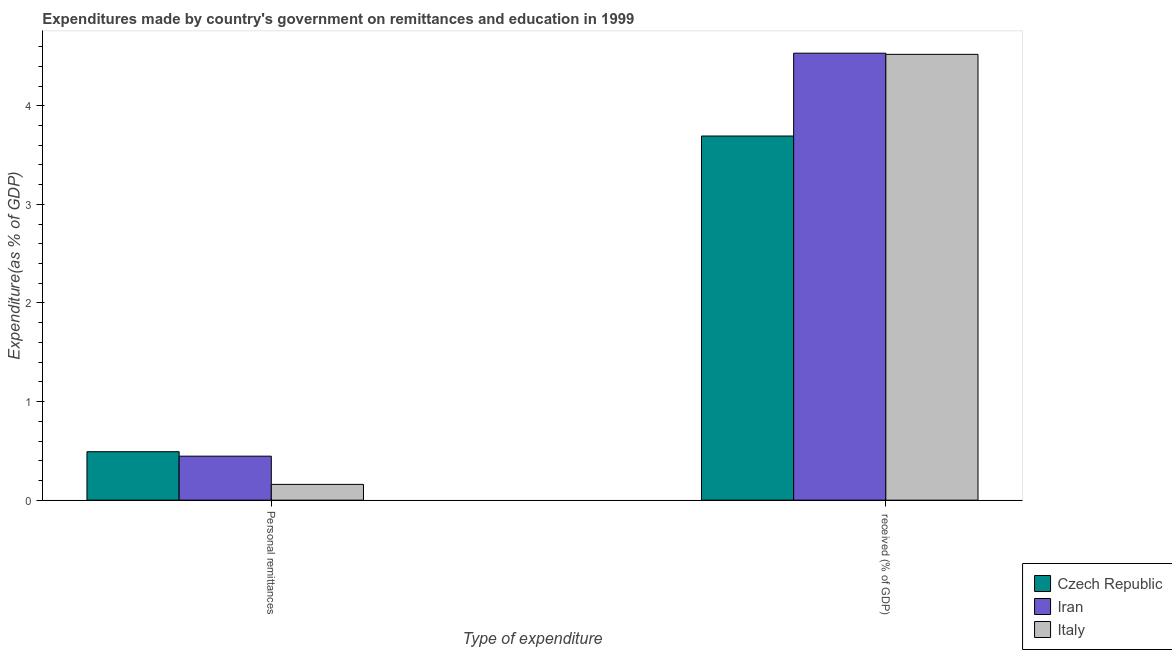How many groups of bars are there?
Make the answer very short. 2. Are the number of bars per tick equal to the number of legend labels?
Offer a terse response. Yes. Are the number of bars on each tick of the X-axis equal?
Keep it short and to the point. Yes. What is the label of the 2nd group of bars from the left?
Provide a short and direct response.  received (% of GDP). What is the expenditure in personal remittances in Czech Republic?
Your answer should be compact. 0.49. Across all countries, what is the maximum expenditure in education?
Offer a very short reply. 4.53. Across all countries, what is the minimum expenditure in education?
Your response must be concise. 3.69. In which country was the expenditure in education maximum?
Your answer should be compact. Iran. In which country was the expenditure in education minimum?
Give a very brief answer. Czech Republic. What is the total expenditure in personal remittances in the graph?
Provide a short and direct response. 1.1. What is the difference between the expenditure in personal remittances in Czech Republic and that in Iran?
Offer a terse response. 0.05. What is the difference between the expenditure in education in Czech Republic and the expenditure in personal remittances in Italy?
Make the answer very short. 3.53. What is the average expenditure in personal remittances per country?
Keep it short and to the point. 0.37. What is the difference between the expenditure in education and expenditure in personal remittances in Czech Republic?
Your answer should be compact. 3.2. What is the ratio of the expenditure in personal remittances in Italy to that in Iran?
Offer a terse response. 0.36. What does the 1st bar from the left in Personal remittances represents?
Provide a short and direct response. Czech Republic. What does the 3rd bar from the right in  received (% of GDP) represents?
Your answer should be compact. Czech Republic. Does the graph contain grids?
Offer a very short reply. No. What is the title of the graph?
Offer a terse response. Expenditures made by country's government on remittances and education in 1999. Does "Greece" appear as one of the legend labels in the graph?
Offer a terse response. No. What is the label or title of the X-axis?
Give a very brief answer. Type of expenditure. What is the label or title of the Y-axis?
Keep it short and to the point. Expenditure(as % of GDP). What is the Expenditure(as % of GDP) of Czech Republic in Personal remittances?
Your answer should be very brief. 0.49. What is the Expenditure(as % of GDP) in Iran in Personal remittances?
Offer a very short reply. 0.45. What is the Expenditure(as % of GDP) of Italy in Personal remittances?
Your response must be concise. 0.16. What is the Expenditure(as % of GDP) in Czech Republic in  received (% of GDP)?
Ensure brevity in your answer.  3.69. What is the Expenditure(as % of GDP) in Iran in  received (% of GDP)?
Offer a very short reply. 4.53. What is the Expenditure(as % of GDP) of Italy in  received (% of GDP)?
Give a very brief answer. 4.52. Across all Type of expenditure, what is the maximum Expenditure(as % of GDP) of Czech Republic?
Ensure brevity in your answer.  3.69. Across all Type of expenditure, what is the maximum Expenditure(as % of GDP) in Iran?
Your answer should be very brief. 4.53. Across all Type of expenditure, what is the maximum Expenditure(as % of GDP) of Italy?
Give a very brief answer. 4.52. Across all Type of expenditure, what is the minimum Expenditure(as % of GDP) of Czech Republic?
Your answer should be compact. 0.49. Across all Type of expenditure, what is the minimum Expenditure(as % of GDP) in Iran?
Your response must be concise. 0.45. Across all Type of expenditure, what is the minimum Expenditure(as % of GDP) of Italy?
Offer a terse response. 0.16. What is the total Expenditure(as % of GDP) in Czech Republic in the graph?
Ensure brevity in your answer.  4.18. What is the total Expenditure(as % of GDP) in Iran in the graph?
Provide a short and direct response. 4.98. What is the total Expenditure(as % of GDP) of Italy in the graph?
Keep it short and to the point. 4.68. What is the difference between the Expenditure(as % of GDP) of Czech Republic in Personal remittances and that in  received (% of GDP)?
Ensure brevity in your answer.  -3.2. What is the difference between the Expenditure(as % of GDP) of Iran in Personal remittances and that in  received (% of GDP)?
Your answer should be very brief. -4.09. What is the difference between the Expenditure(as % of GDP) of Italy in Personal remittances and that in  received (% of GDP)?
Offer a very short reply. -4.36. What is the difference between the Expenditure(as % of GDP) in Czech Republic in Personal remittances and the Expenditure(as % of GDP) in Iran in  received (% of GDP)?
Provide a short and direct response. -4.04. What is the difference between the Expenditure(as % of GDP) in Czech Republic in Personal remittances and the Expenditure(as % of GDP) in Italy in  received (% of GDP)?
Your response must be concise. -4.03. What is the difference between the Expenditure(as % of GDP) of Iran in Personal remittances and the Expenditure(as % of GDP) of Italy in  received (% of GDP)?
Your response must be concise. -4.08. What is the average Expenditure(as % of GDP) of Czech Republic per Type of expenditure?
Provide a succinct answer. 2.09. What is the average Expenditure(as % of GDP) of Iran per Type of expenditure?
Make the answer very short. 2.49. What is the average Expenditure(as % of GDP) of Italy per Type of expenditure?
Keep it short and to the point. 2.34. What is the difference between the Expenditure(as % of GDP) of Czech Republic and Expenditure(as % of GDP) of Iran in Personal remittances?
Your answer should be compact. 0.05. What is the difference between the Expenditure(as % of GDP) in Czech Republic and Expenditure(as % of GDP) in Italy in Personal remittances?
Your answer should be very brief. 0.33. What is the difference between the Expenditure(as % of GDP) of Iran and Expenditure(as % of GDP) of Italy in Personal remittances?
Offer a terse response. 0.29. What is the difference between the Expenditure(as % of GDP) of Czech Republic and Expenditure(as % of GDP) of Iran in  received (% of GDP)?
Provide a short and direct response. -0.84. What is the difference between the Expenditure(as % of GDP) of Czech Republic and Expenditure(as % of GDP) of Italy in  received (% of GDP)?
Make the answer very short. -0.83. What is the difference between the Expenditure(as % of GDP) in Iran and Expenditure(as % of GDP) in Italy in  received (% of GDP)?
Give a very brief answer. 0.01. What is the ratio of the Expenditure(as % of GDP) in Czech Republic in Personal remittances to that in  received (% of GDP)?
Offer a terse response. 0.13. What is the ratio of the Expenditure(as % of GDP) in Iran in Personal remittances to that in  received (% of GDP)?
Your answer should be very brief. 0.1. What is the ratio of the Expenditure(as % of GDP) of Italy in Personal remittances to that in  received (% of GDP)?
Provide a succinct answer. 0.04. What is the difference between the highest and the second highest Expenditure(as % of GDP) in Czech Republic?
Provide a succinct answer. 3.2. What is the difference between the highest and the second highest Expenditure(as % of GDP) in Iran?
Provide a short and direct response. 4.09. What is the difference between the highest and the second highest Expenditure(as % of GDP) in Italy?
Offer a terse response. 4.36. What is the difference between the highest and the lowest Expenditure(as % of GDP) in Czech Republic?
Offer a very short reply. 3.2. What is the difference between the highest and the lowest Expenditure(as % of GDP) in Iran?
Offer a very short reply. 4.09. What is the difference between the highest and the lowest Expenditure(as % of GDP) in Italy?
Offer a very short reply. 4.36. 